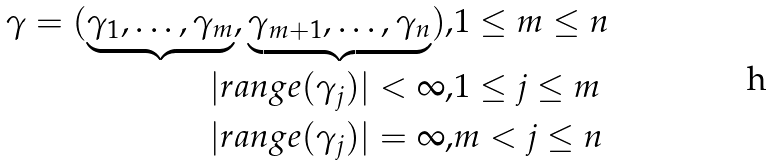<formula> <loc_0><loc_0><loc_500><loc_500>\gamma = ( \underbrace { \gamma _ { 1 } , \dots , \gamma _ { m } } , \underbrace { \gamma _ { m + 1 } , \dots , \gamma _ { n } } ) , & 1 \leq m \leq n \\ | r a n g e ( \gamma _ { j } ) | < \infty , & 1 \leq j \leq m \\ | r a n g e ( \gamma _ { j } ) | = \infty , & m < j \leq n \\</formula> 